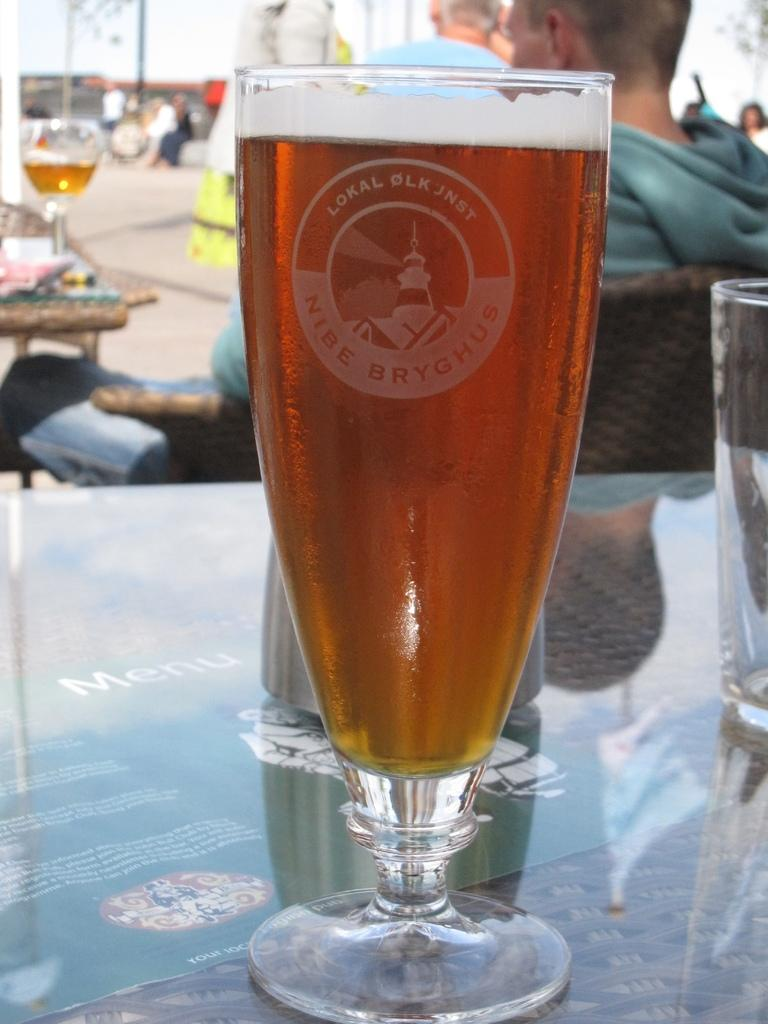<image>
Write a terse but informative summary of the picture. A tall glass of beer bears a lighthouse on its logo and the words Nibe Bryghus. 